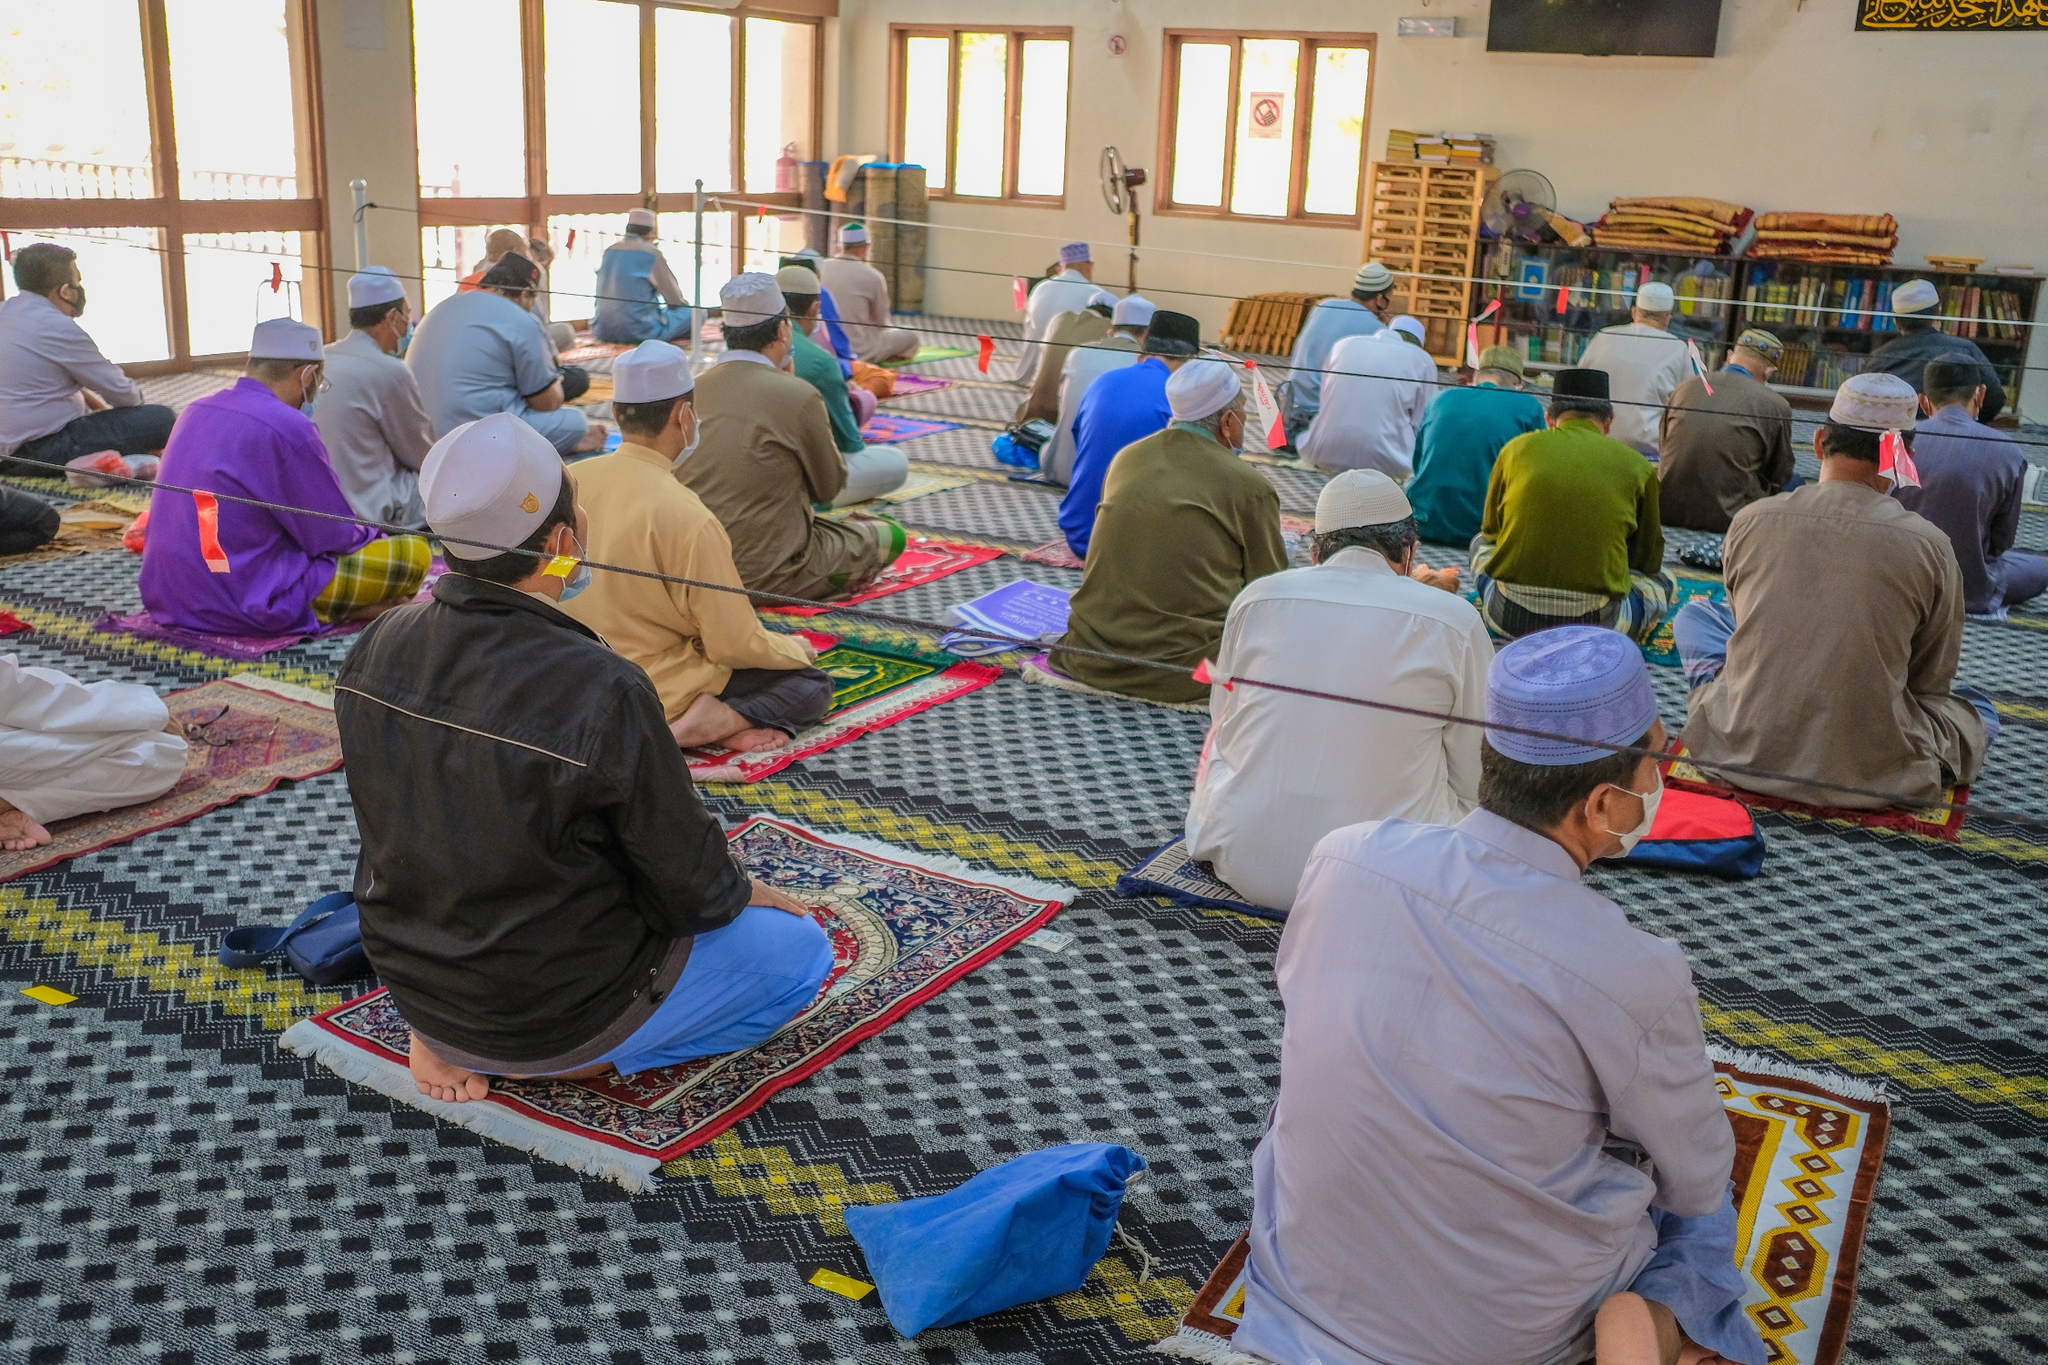Can you describe the architectural features visible in this mosque? The mosque in the image features a high, airy ceiling supported by visible beams, which suggests good ventilation and acoustics essential for the clarity of prayer calls and sermons. Large, arched windows allow for abundant natural light, contributing to an open and welcoming atmosphere. The walls are minimally adorned but include essential bookshelves filled with religious texts, signifying the mosque's dual function as a place for worship and learning. The choice of simple yet functional design elements reflects the practical and spiritual needs of the community it serves. 